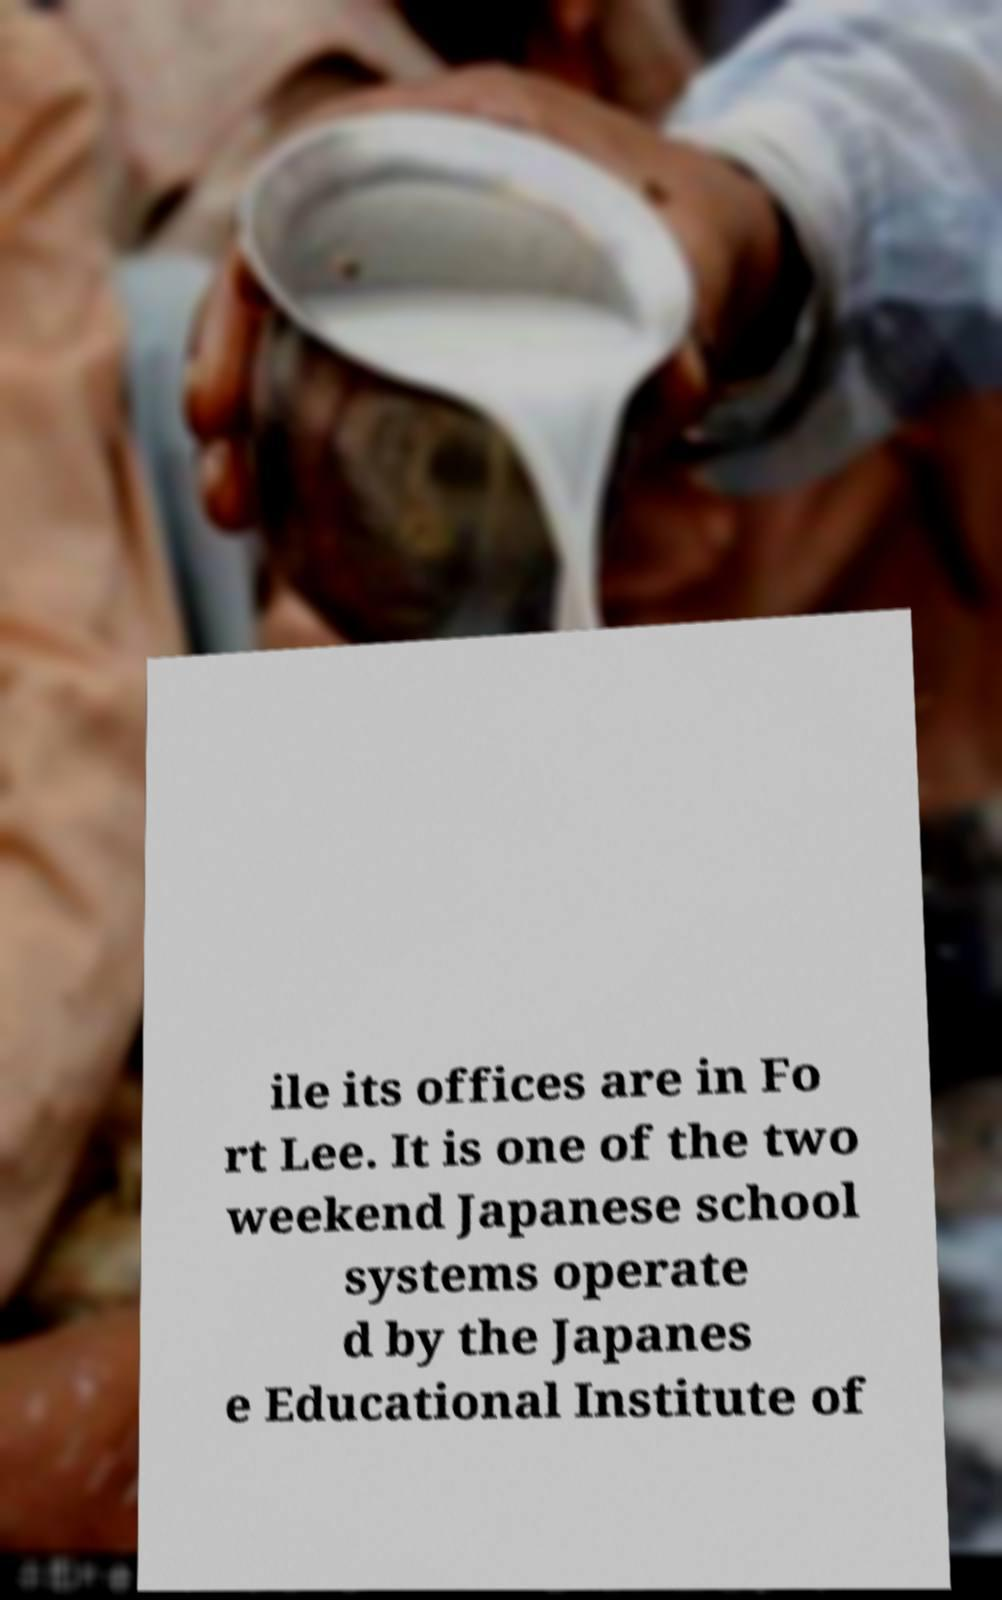There's text embedded in this image that I need extracted. Can you transcribe it verbatim? ile its offices are in Fo rt Lee. It is one of the two weekend Japanese school systems operate d by the Japanes e Educational Institute of 